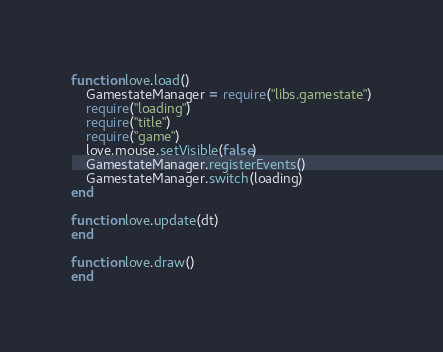Convert code to text. <code><loc_0><loc_0><loc_500><loc_500><_Lua_>function love.load()
    GamestateManager = require("libs.gamestate")
    require("loading")
    require("title")
    require("game")
    love.mouse.setVisible(false)
    GamestateManager.registerEvents()
    GamestateManager.switch(loading)
end

function love.update(dt)
end

function love.draw()
end
</code> 